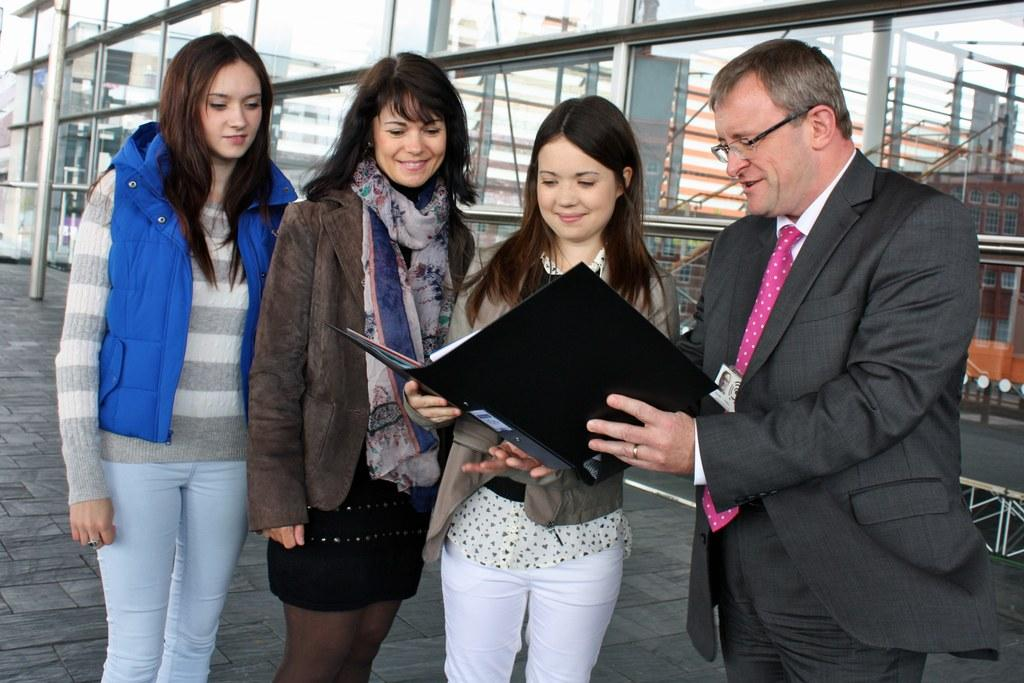How many people are present in the image? There are four people in the image. What are two of the people doing with a book? Two of the people are holding a book. What can be seen in the background of the image? There is a building in the background of the image. What type of disease is affecting the people in the image? There is no indication of any disease affecting the people in the image. Can you describe the curve of the building in the background? The facts provided do not mention any specific details about the shape or curve of the building in the background. 